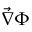<formula> <loc_0><loc_0><loc_500><loc_500>\vec { \nabla } \Phi</formula> 